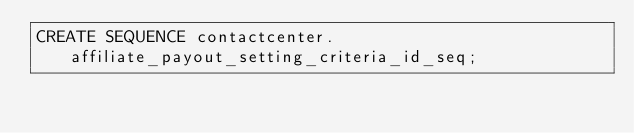<code> <loc_0><loc_0><loc_500><loc_500><_SQL_>CREATE SEQUENCE contactcenter.affiliate_payout_setting_criteria_id_seq;
</code> 